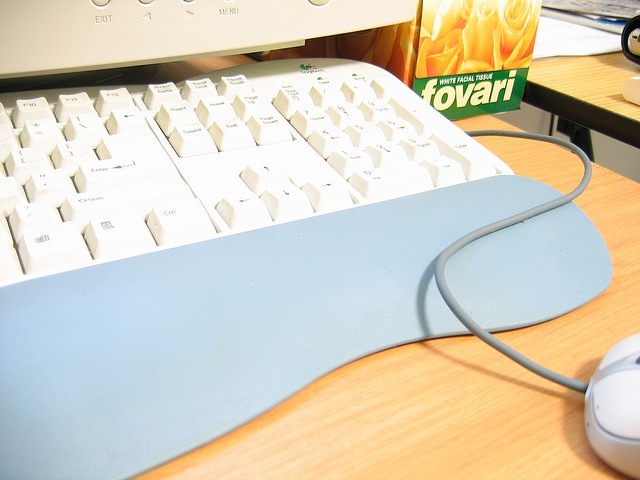Describe the objects in this image and their specific colors. I can see keyboard in lightgray, tan, lightblue, darkgray, and beige tones, tv in tan and ivory tones, and mouse in tan, lightgray, and darkgray tones in this image. 